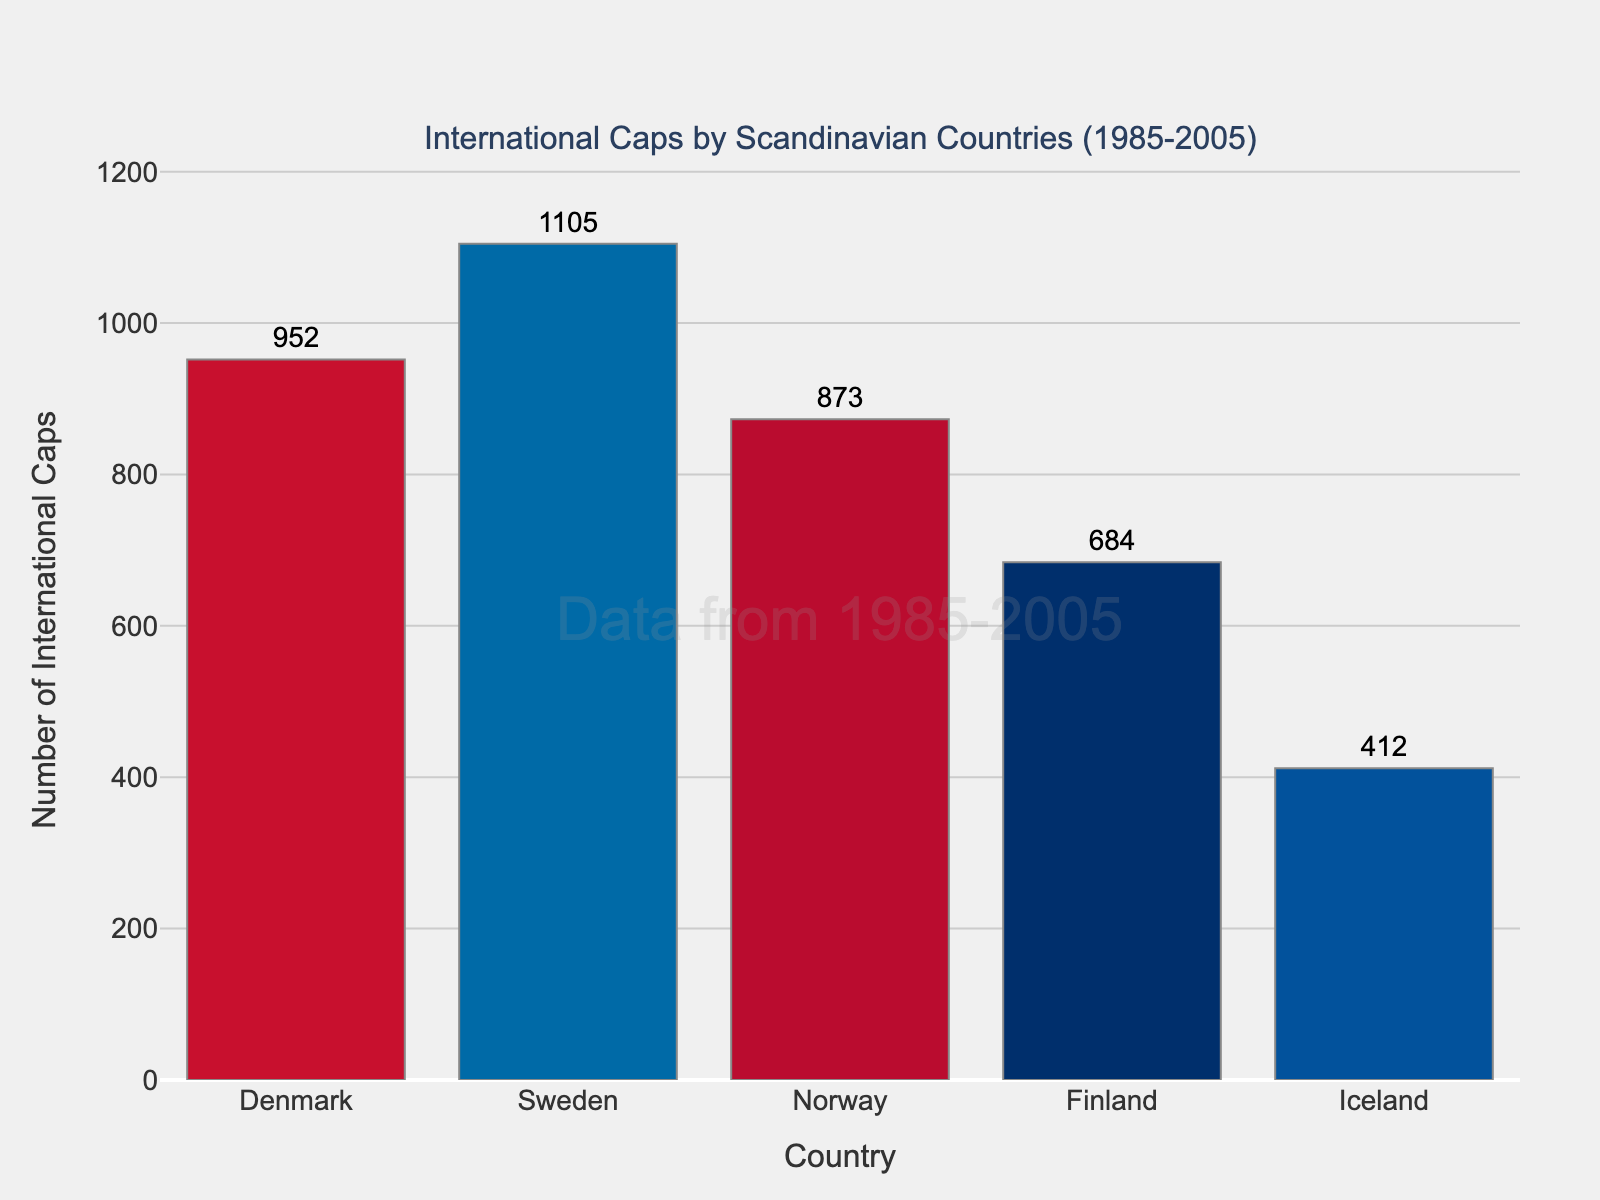Which country has the highest number of international caps? Looking at the heights of the bars, Sweden's bar is the tallest, indicating that Sweden has the highest number of international caps.
Answer: Sweden Among the Scandinavian countries listed, which one has the lowest number of international caps? The shortest bar in the chart corresponds to Iceland, indicating that Iceland has the lowest number of international caps.
Answer: Iceland What is the total number of international caps earned by Denmark and Norway combined? Referring to the bars for Denmark and Norway, Denmark has 952 caps and Norway has 873 caps. Summing these gives 952 + 873.
Answer: 1825 Which country has about twice as many caps as Finland? Finland has 684 caps. Doubling this would be 2 * 684 = 1368. None of the countries have exactly this number, but Sweden with 1105 caps is close to twice Finland's total.
Answer: Sweden Compare the number of international caps earned by Denmark and Finland. Which country has more and by how much? Denmark has 952 caps and Finland has 684 caps. Subtract the smaller number from the larger: 952 - 684.
Answer: Denmark, by 268 caps Rank the five countries from highest to lowest based on their international caps. By observing the heights of the bars, we rank them as: Sweden (1105), Denmark (952), Norway (873), Finland (684), and Iceland (412).
Answer: Sweden, Denmark, Norway, Finland, Iceland What is the average number of international caps earned by the five countries? Sum the total international caps from all five countries: 952 + 1105 + 873 + 684 + 412 = 4026. Dividing by the number of countries (5) gives 4026 / 5.
Answer: 805.2 Which country's number of international caps is closest to the average value of the five countries? The average is 805.2. Comparing Denmark (952), Sweden (1105), Norway (873), Finland (684), and Iceland (412), the closest value is Norway with 873 caps.
Answer: Norway 